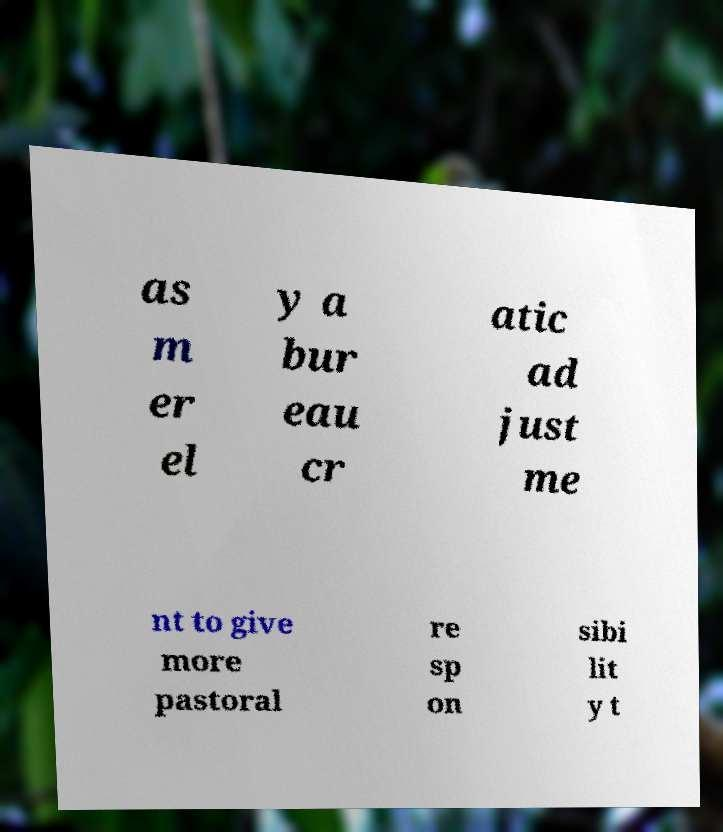Could you extract and type out the text from this image? as m er el y a bur eau cr atic ad just me nt to give more pastoral re sp on sibi lit y t 